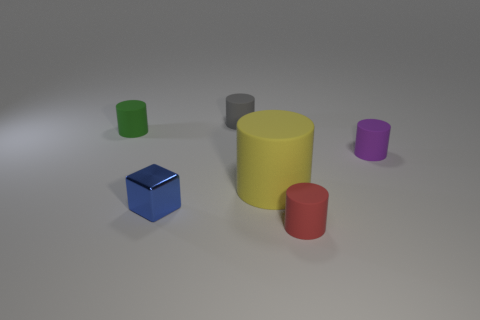Is there anything else that has the same size as the metallic thing?
Your answer should be very brief. Yes. Does the small rubber thing left of the gray matte thing have the same shape as the purple rubber thing that is to the right of the gray matte cylinder?
Your answer should be compact. Yes. Are there more tiny purple objects left of the blue metal object than purple metallic balls?
Provide a short and direct response. No. How many objects are green rubber cylinders or purple cylinders?
Make the answer very short. 2. The metal block is what color?
Make the answer very short. Blue. What number of other objects are the same color as the large matte cylinder?
Offer a terse response. 0. Are there any cubes in front of the tiny metal cube?
Your answer should be compact. No. The small cylinder that is in front of the matte cylinder that is right of the cylinder that is in front of the large yellow cylinder is what color?
Give a very brief answer. Red. How many tiny objects are in front of the gray rubber cylinder and to the left of the small purple rubber cylinder?
Your answer should be compact. 3. What number of spheres are either green things or purple matte things?
Offer a very short reply. 0. 